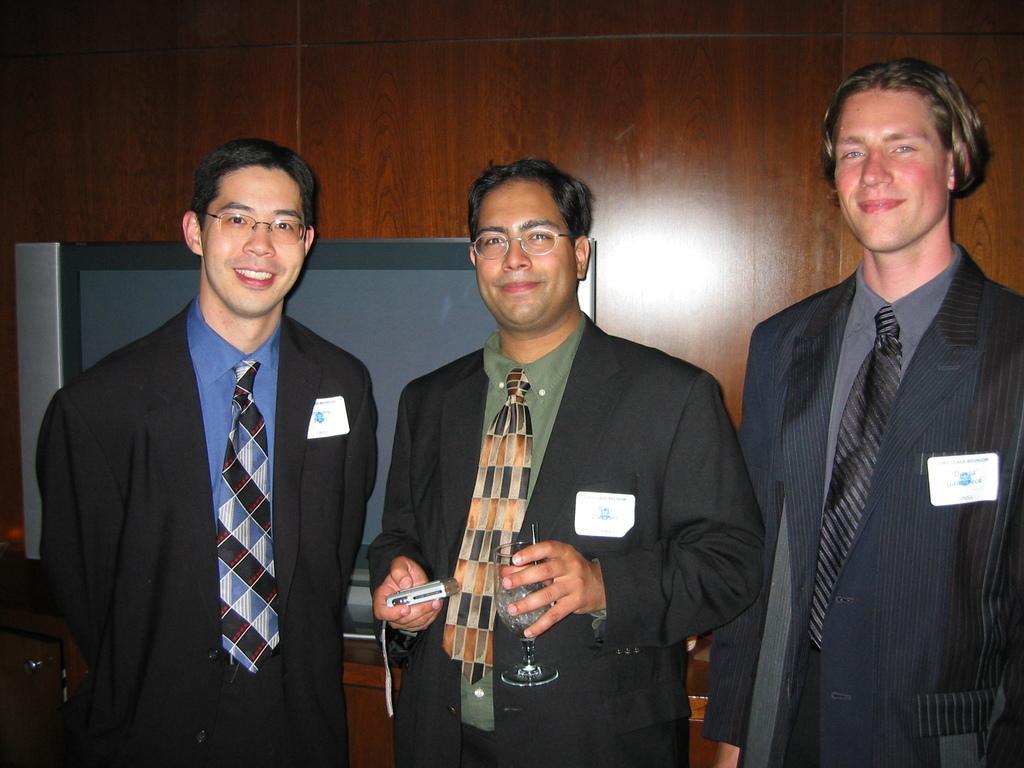Could you give a brief overview of what you see in this image? In this image there are three men standing one is holding a glass and a camera in his hand, in the background there is a wooden wall and a TV. 